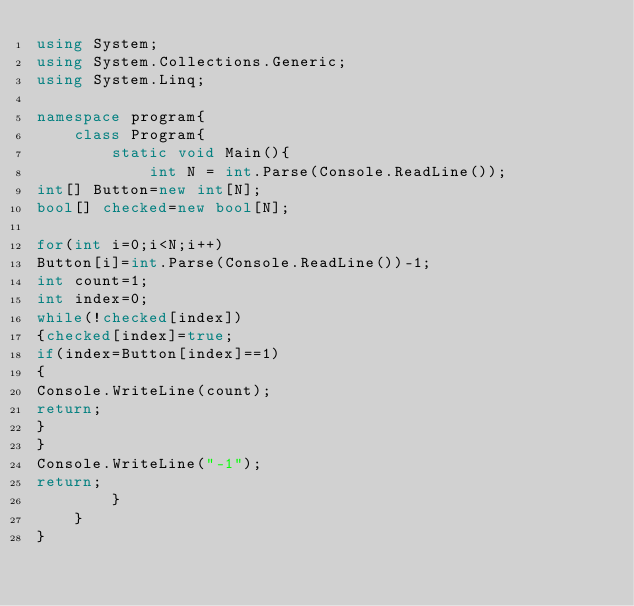Convert code to text. <code><loc_0><loc_0><loc_500><loc_500><_C#_>using System;
using System.Collections.Generic;
using System.Linq;

namespace program{
	class Program{
		static void Main(){
			int N = int.Parse(Console.ReadLine());
int[] Button=new int[N];
bool[] checked=new bool[N];

for(int i=0;i<N;i++)
Button[i]=int.Parse(Console.ReadLine())-1;
int count=1;
int index=0;
while(!checked[index])
{checked[index]=true;
if(index=Button[index]==1)
{
Console.WriteLine(count);
return;
}
}
Console.WriteLine("-1");
return;
		}
	}
}

</code> 